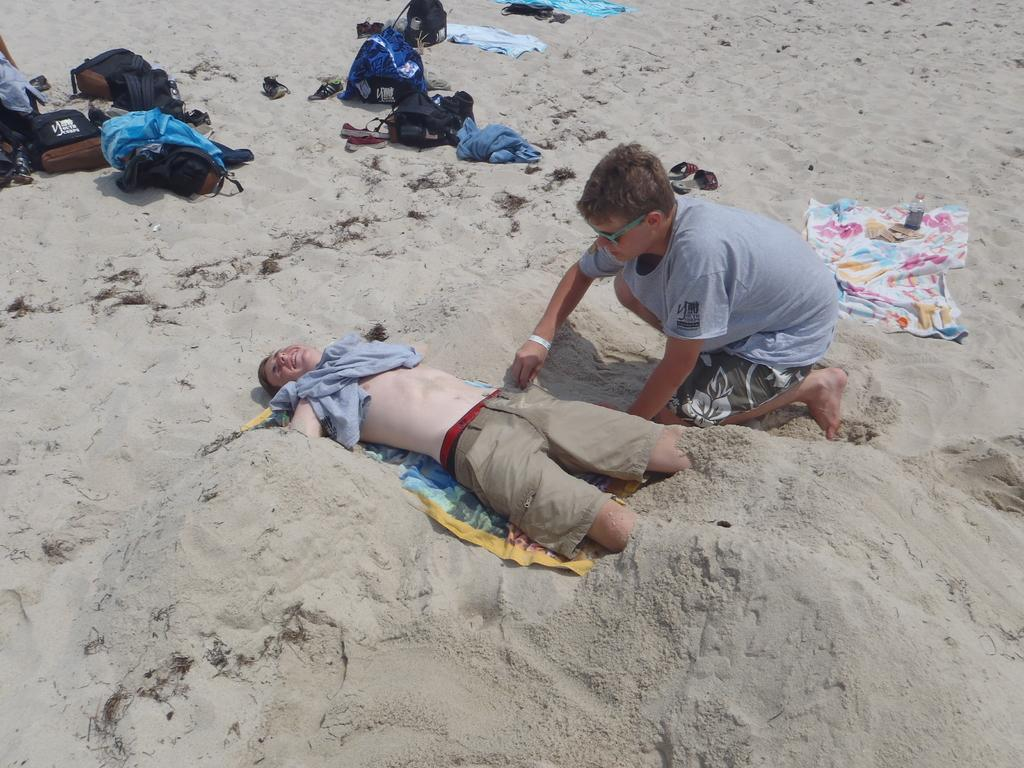What is the person in the image doing? There is a person lying in the sand in the image. Where is the boy located in the image? The boy is on the right side of the image. What items can be seen in the image besides the people? There are bags and clothes visible in the image. What type of smile can be seen on the office in the image? There is no office present in the image, and therefore no smile can be observed on it. 